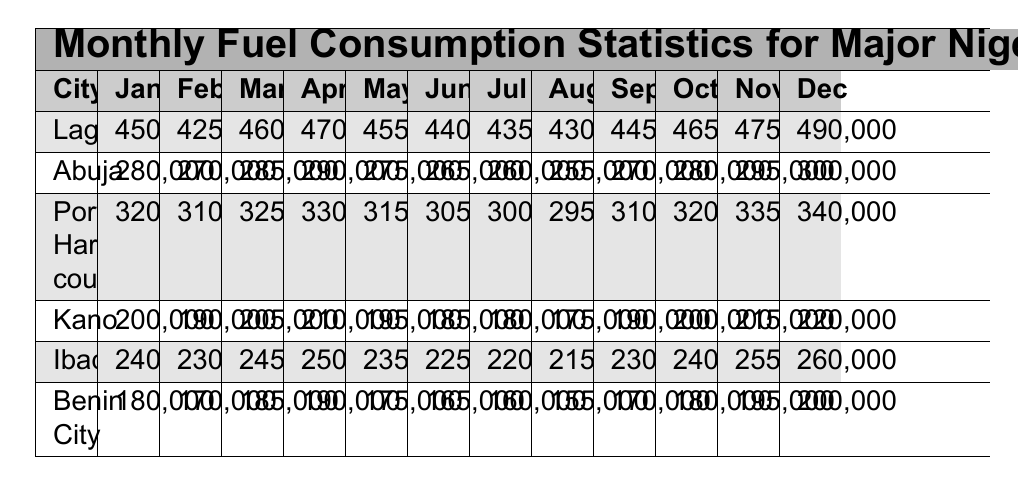What city had the highest fuel consumption in December? The table indicates that Lagos had the highest fuel consumption in December with 490,000 liters.
Answer: Lagos What was the fuel consumption for Kano in March? In the table, Kano's fuel consumption in March is recorded as 205,000 liters.
Answer: 205000 What is the average monthly fuel consumption for Abuja for the year? To find the average for Abuja, we sum the monthly consumptions: (280000 + 270000 + 285000 + 290000 + 275000 + 265000 + 260000 + 255000 + 270000 + 280000 + 295000 + 300000) = 3,165,000 liters; then divide by 12 months: 3,165,000 / 12 = 263,750.
Answer: 263750 Did Port Harcourt's fuel consumption decrease from June to July? According to the table, Port Harcourt's consumption was 305,000 liters in June and decreased to 300,000 liters in July, confirming a decrease.
Answer: Yes Which city had the lowest fuel consumption in August? The table shows that Kano had the lowest fuel consumption in August, with 175,000 liters.
Answer: Kano What is the total fuel consumption for Lagos from January to March? To calculate this, we sum Lagos's consumption for January (450,000), February (425,000), and March (460,000): 450000 + 425000 + 460000 = 1,335,000 liters.
Answer: 1335000 Which month had the highest fuel consumption for Ibadan? The table displays that November had the highest consumption for Ibadan at 255,000 liters.
Answer: November Is the total fuel consumption for Benin City in the first half of the year greater than 1 million liters? The total for Benin City from January to June is (180000 + 170000 + 185000 + 190000 + 175000 + 165000) = 1,060,000 liters, which is more than 1 million.
Answer: Yes Using the data for October, which city had a consumption closest to 300,000 liters? The table states that Abuja had 280,000 liters, which is closest to 300,000 liters when compared to other cities in October.
Answer: Abuja Calculate the increase in fuel consumption for Kano from January to December. Kano's consumption increased from 200,000 liters in January to 220,000 liters in December, giving an increase of 20,000 liters.
Answer: 20000 